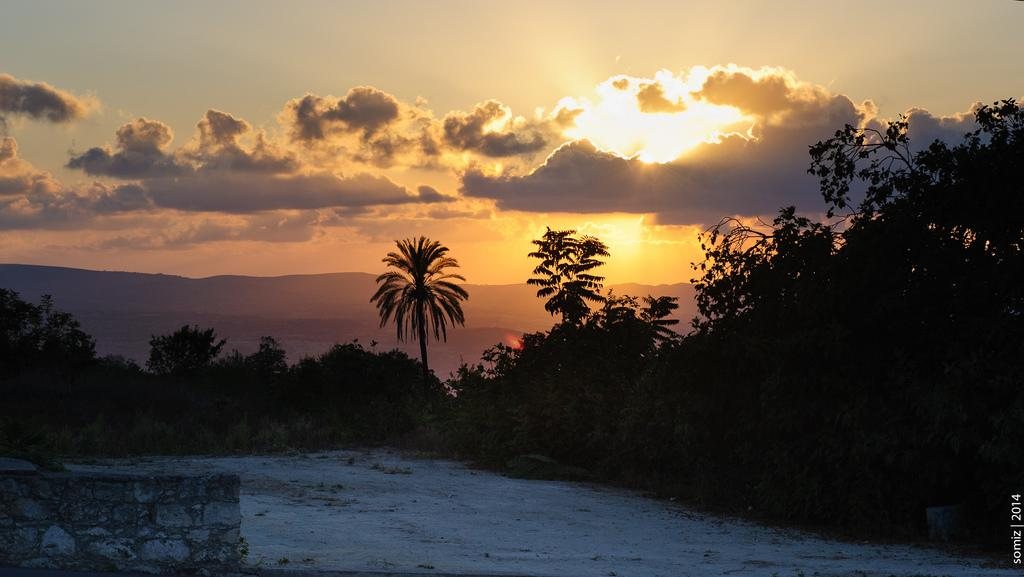What type of natural environment can be seen in the background of the image? There are trees in the background of the image. What is visible in the sky in the background of the image? The sky is visible in the background of the image, along with clouds and the sun. What is located at the bottom of the image? There is a wall at the bottom of the image. What type of terrain is present in the image? There is sand in the image. Can you tell me how many pets are walking on the sand in the image? There are no pets present in the image, and therefore no such activity can be observed. Where is the kettle located in the image? There is no kettle present in the image. 